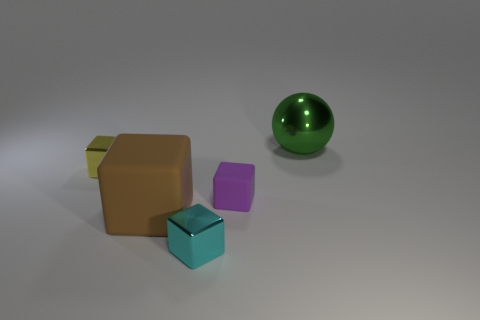Subtract 1 blocks. How many blocks are left? 3 Add 3 tiny yellow blocks. How many objects exist? 8 Subtract all spheres. How many objects are left? 4 Subtract all balls. Subtract all yellow metal things. How many objects are left? 3 Add 4 metallic objects. How many metallic objects are left? 7 Add 1 metal blocks. How many metal blocks exist? 3 Subtract 0 purple cylinders. How many objects are left? 5 